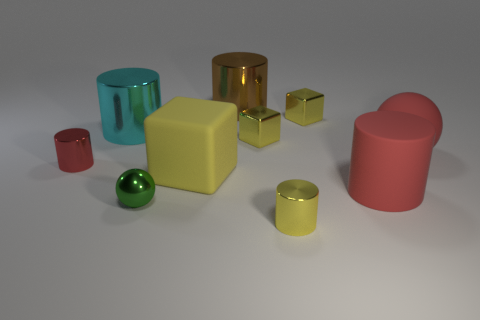Are there more small brown shiny cubes than big yellow matte objects?
Make the answer very short. No. There is a metal cylinder that is in front of the small cylinder that is behind the metallic cylinder in front of the green thing; what is its size?
Provide a short and direct response. Small. There is a metal cylinder in front of the tiny green metallic thing; what is its size?
Keep it short and to the point. Small. What number of objects are blue spheres or tiny things that are in front of the big yellow rubber block?
Your response must be concise. 2. How many other things are the same size as the green shiny sphere?
Keep it short and to the point. 4. What is the material of the big red object that is the same shape as the big cyan object?
Keep it short and to the point. Rubber. Are there more red cylinders behind the rubber block than big blue things?
Keep it short and to the point. Yes. Are there any other things that have the same color as the metal sphere?
Ensure brevity in your answer.  No. There is a green object that is made of the same material as the brown object; what shape is it?
Keep it short and to the point. Sphere. Are the cube in front of the red shiny cylinder and the cyan thing made of the same material?
Ensure brevity in your answer.  No. 